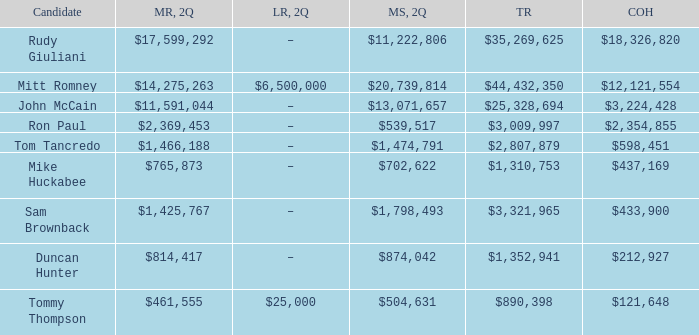Name the money spent for 2Q having candidate of john mccain $13,071,657. 